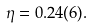<formula> <loc_0><loc_0><loc_500><loc_500>\eta = 0 . 2 4 ( 6 ) .</formula> 